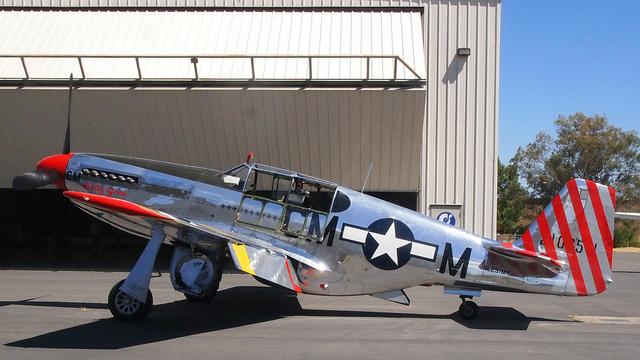Does this item appear to be lovingly restored?
Be succinct. Yes. What shape are the windows on the side of the plane?
Be succinct. Rectangle. Is this a commercial plane?
Write a very short answer. No. Is the plane flying?
Short answer required. No. Does this plane likely get stored indoors or outdoors?
Give a very brief answer. Indoors. 